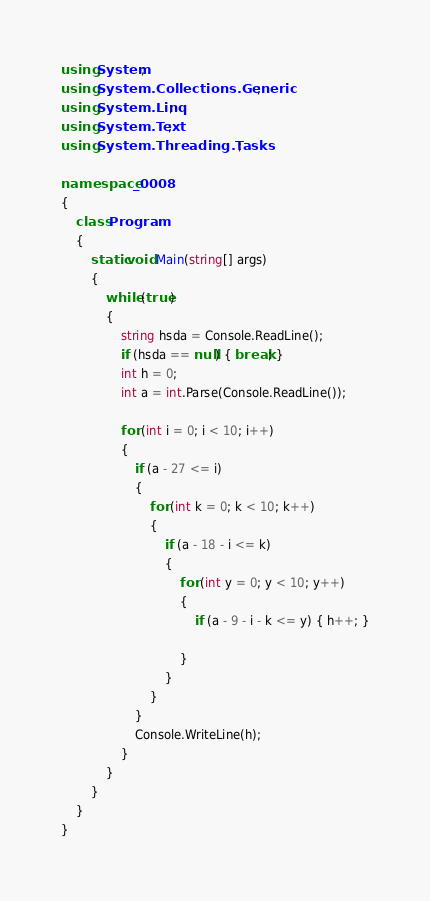<code> <loc_0><loc_0><loc_500><loc_500><_C#_>using System;
using System.Collections.Generic;
using System.Linq;
using System.Text;
using System.Threading.Tasks;

namespace _0008
{
    class Program
    {
        static void Main(string[] args)
        {
            while (true)
            {
                string hsda = Console.ReadLine();
                if (hsda == null) { break; }
                int h = 0;
                int a = int.Parse(Console.ReadLine());
                
                for (int i = 0; i < 10; i++)
                {
                    if (a - 27 <= i)
                    {
                        for (int k = 0; k < 10; k++)
                        {
                            if (a - 18 - i <= k)
                            {
                                for (int y = 0; y < 10; y++)
                                {
                                    if (a - 9 - i - k <= y) { h++; }
                                      
                                }
                            }
                        }
                    }
                    Console.WriteLine(h);
                }
            }
        }
    }
}</code> 